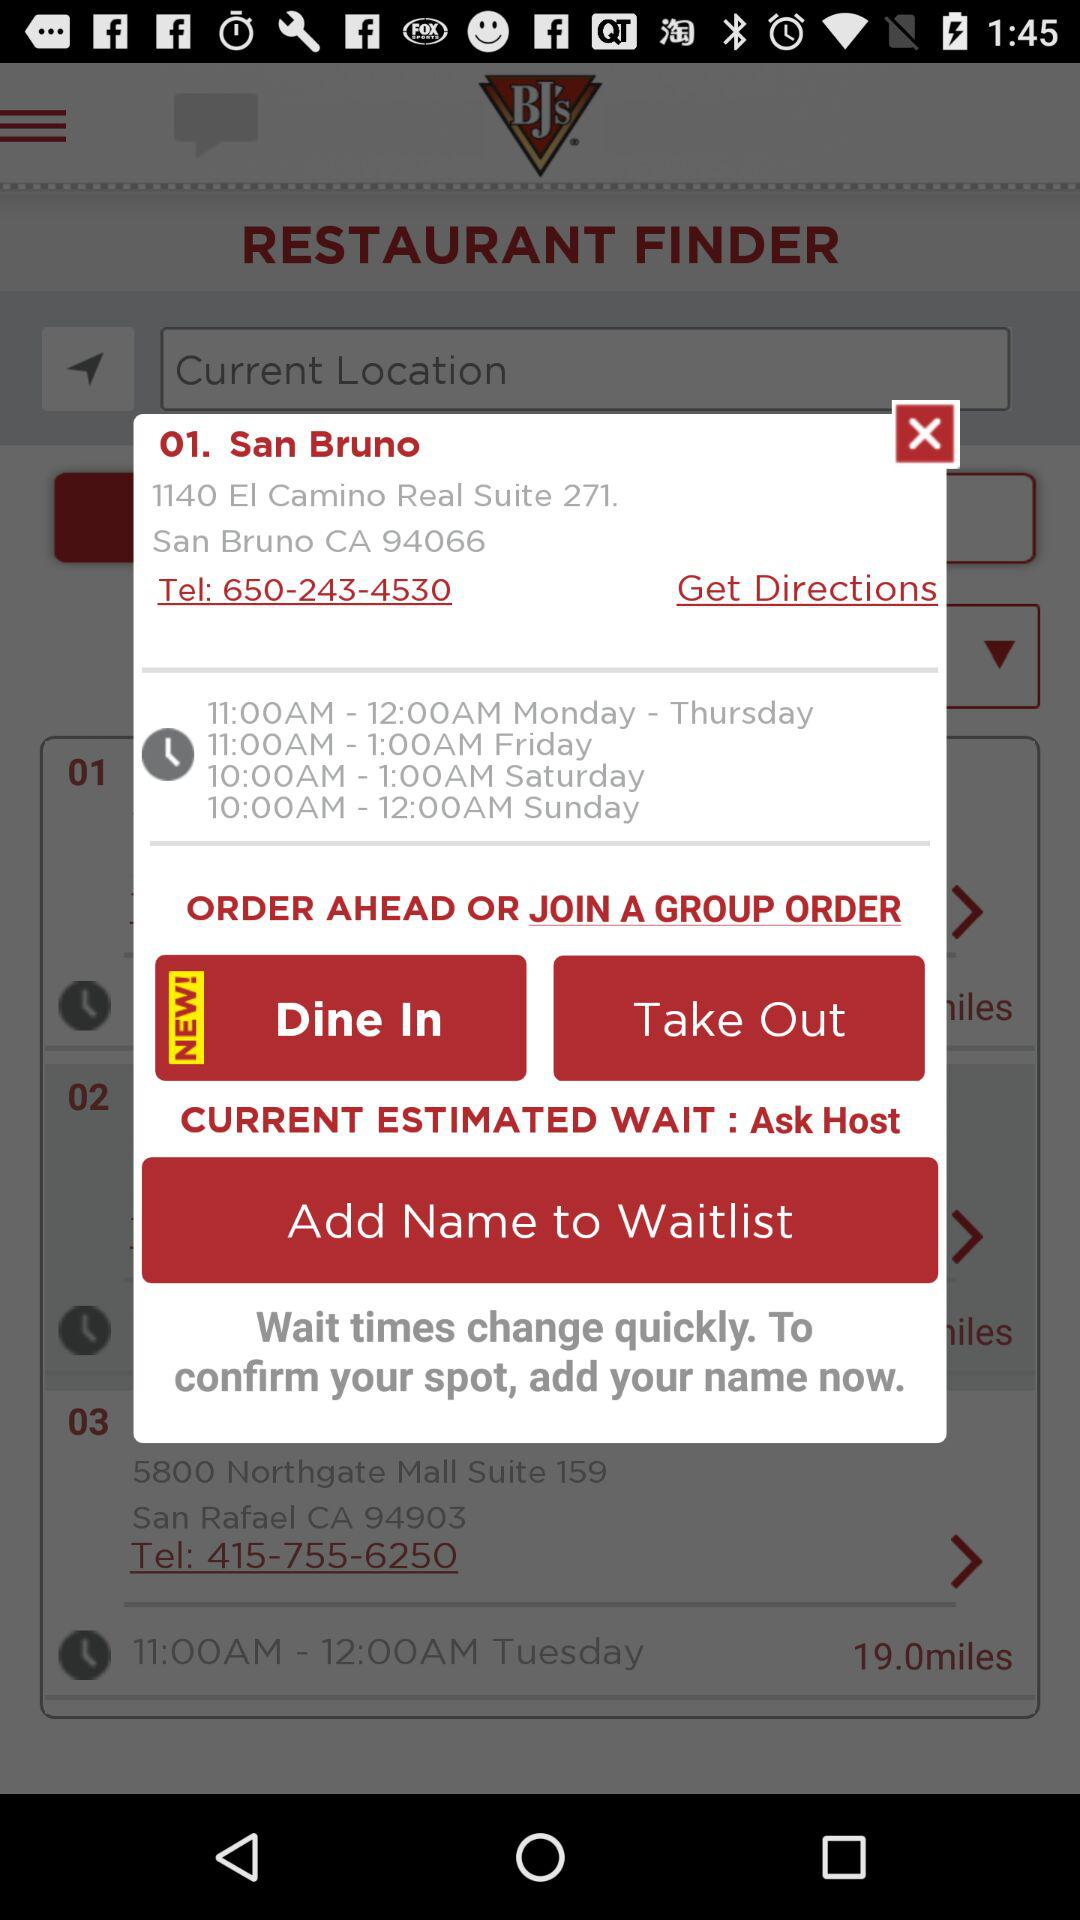What is the address of the restaurant located in San Bruno? The address of the restaurant located in San Bruno is 1140 El Camino Real Suite 271. San Bruno, CA 94066. 